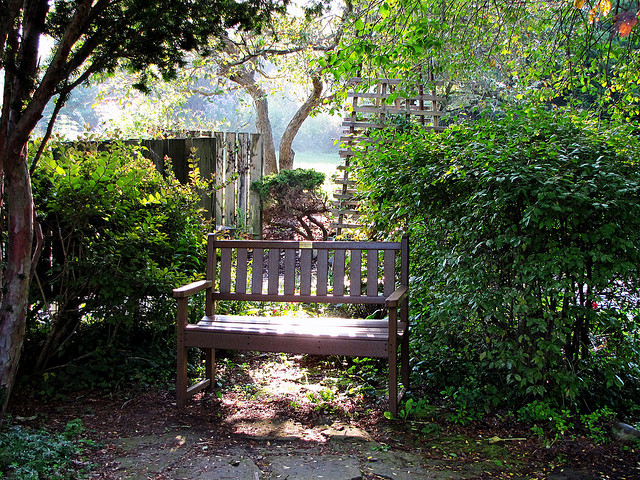<image>What type of chair is the bear sitting in? I don't know what type of chair the bear is sitting in. There might not be a bear in the image. What type of chair is the bear sitting in? I don't know what type of chair the bear is sitting in. It can be seen both 'bench' and 'wood'. 